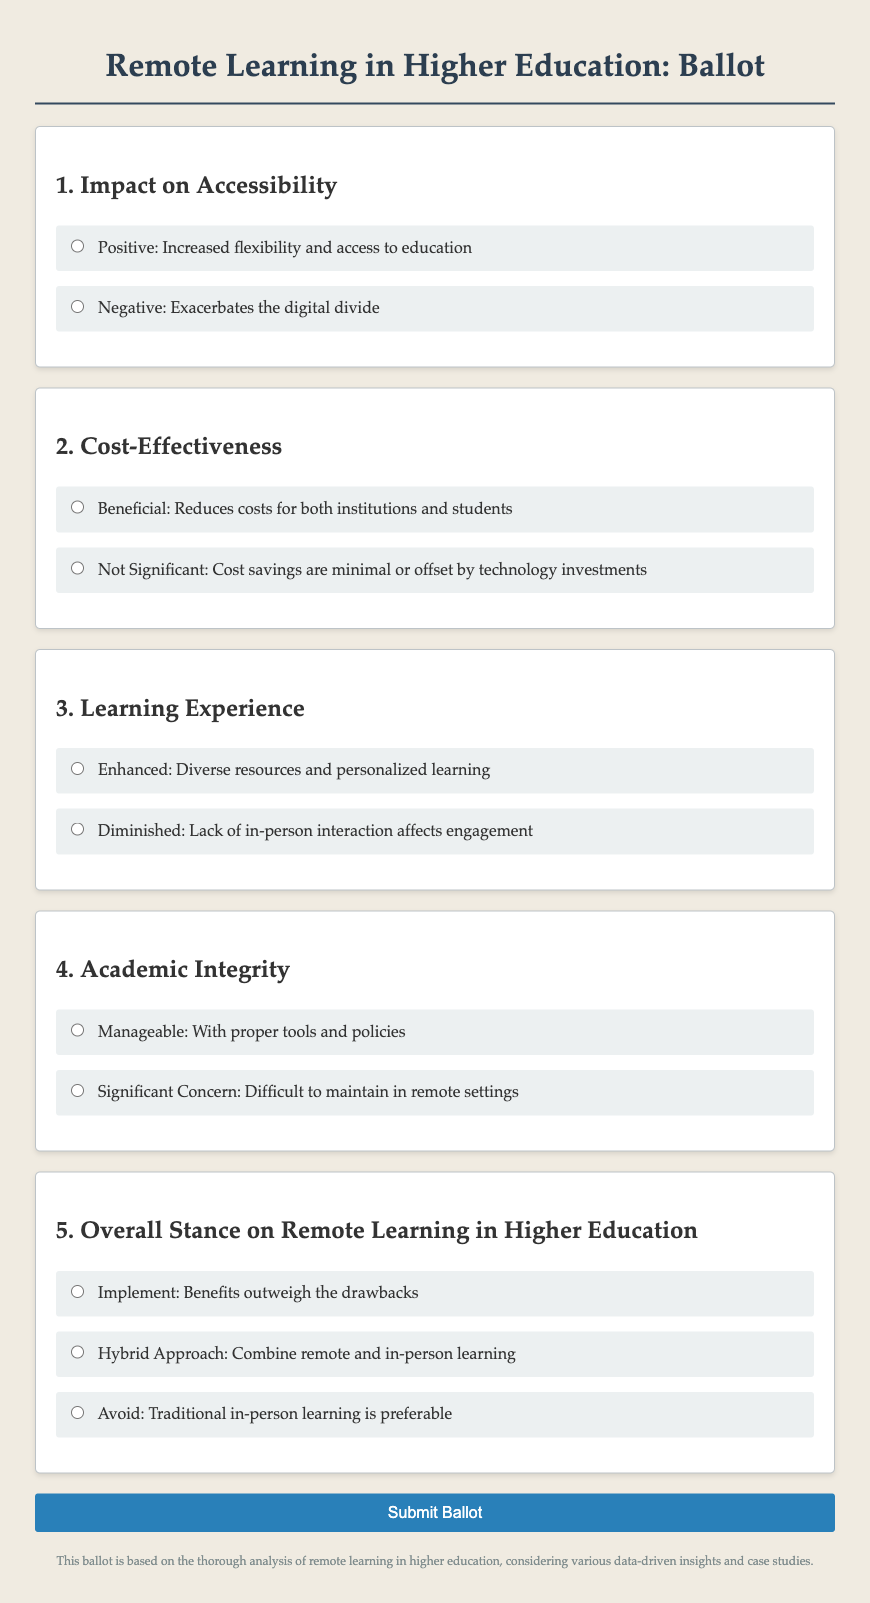What is the title of the ballot? The title is stated prominently at the top of the document, indicating the subject matter of the ballot.
Answer: Remote Learning in Higher Education: Ballot How many sections are there in the ballot? The document contains five distinct sections, each addressing a different aspect of remote learning.
Answer: Five What is the first option under Impact on Accessibility? The options presented under each question are clearly delineated in the sections, with the first being a positive perspective.
Answer: Positive: Increased flexibility and access to education What type of approach does the ballot suggest for the overall stance on remote learning? The ballot provides multiple choices regarding the overall stance, indicating varying degrees of support or opposition.
Answer: Hybrid Approach: Combine remote and in-person learning What is the color of the submit button? The color of the button is specified in the style section of the document, making it visually distinctive.
Answer: Blue Which concern is raised under Academic Integrity? This reflects the potential challenges faced in maintaining standards while learning remotely.
Answer: Significant Concern: Difficult to maintain in remote settings What is the content of the footnote? The footnote provides a brief summary regarding the basis of the ballot, emphasizing its comprehensive approach.
Answer: This ballot is based on the thorough analysis of remote learning in higher education, considering various data-driven insights and case studies 